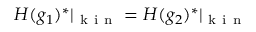Convert formula to latex. <formula><loc_0><loc_0><loc_500><loc_500>H ( g _ { 1 } ) ^ { * } | _ { k i n } = H ( g _ { 2 } ) ^ { * } | _ { k i n }</formula> 